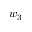Convert formula to latex. <formula><loc_0><loc_0><loc_500><loc_500>w _ { 3 }</formula> 